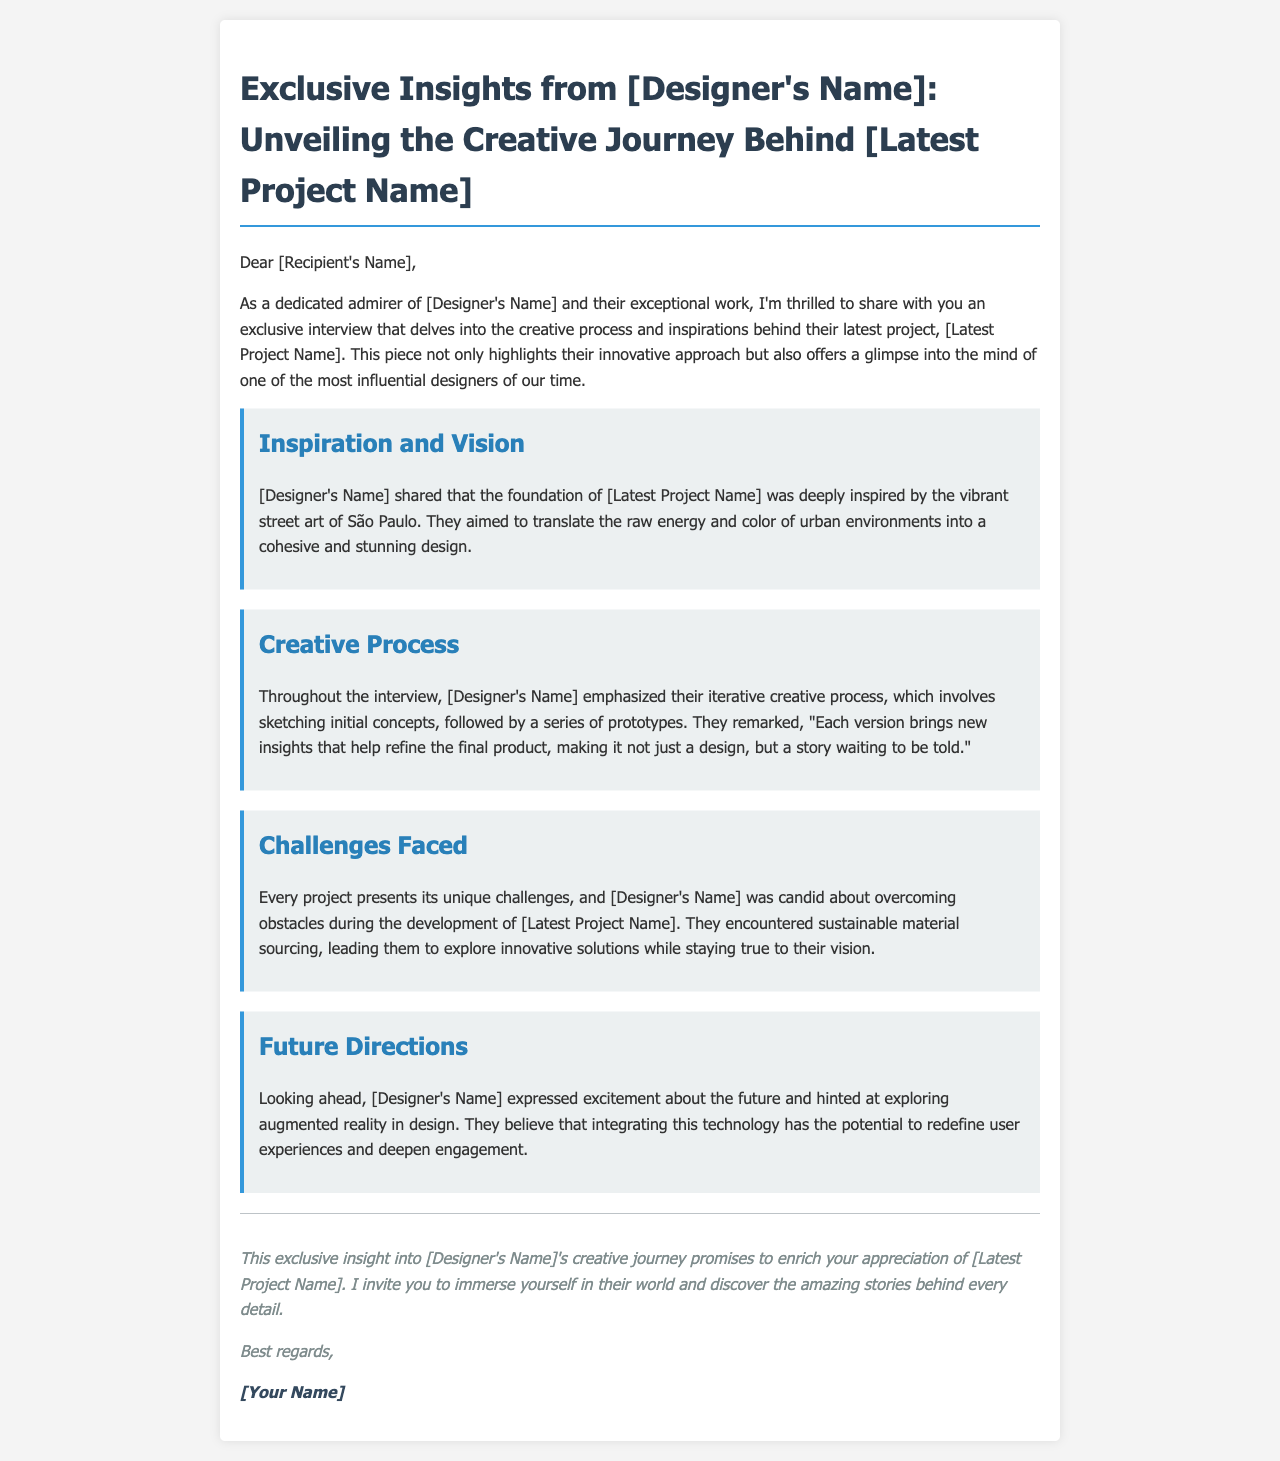What is the name of the designer featured in the interview? The document references the designer throughout but does not provide a specific name in the given text.
Answer: [Designer's Name] What is the latest project discussed in the email? The email title mentions this project, highlighting it as the subject of the interview.
Answer: [Latest Project Name] What city inspired the foundation of the latest project? The document explicitly states that the vibrant street art of this city served as the inspiration.
Answer: São Paulo What type of process did the designer emphasize as part of their creative journey? The designer's approach to their work is characterized in the document, focusing on a specific method.
Answer: Iterative What challenge did the designer face during the development of the latest project? The document mentions a particular issue that arose during the project’s development.
Answer: Sustainable material sourcing What future technology does the designer express excitement about exploring? The email hints at a technological avenue that the designer is keen to investigate further.
Answer: Augmented reality What is the overall purpose of the email? The primary aim of this correspondence is clearly stated in the opening lines of the document.
Answer: To share an exclusive interview How does the designer view the final product of their work? The designer's perspective on the outcome of their efforts is summarized in a specific phrase in the document.
Answer: A story waiting to be told 